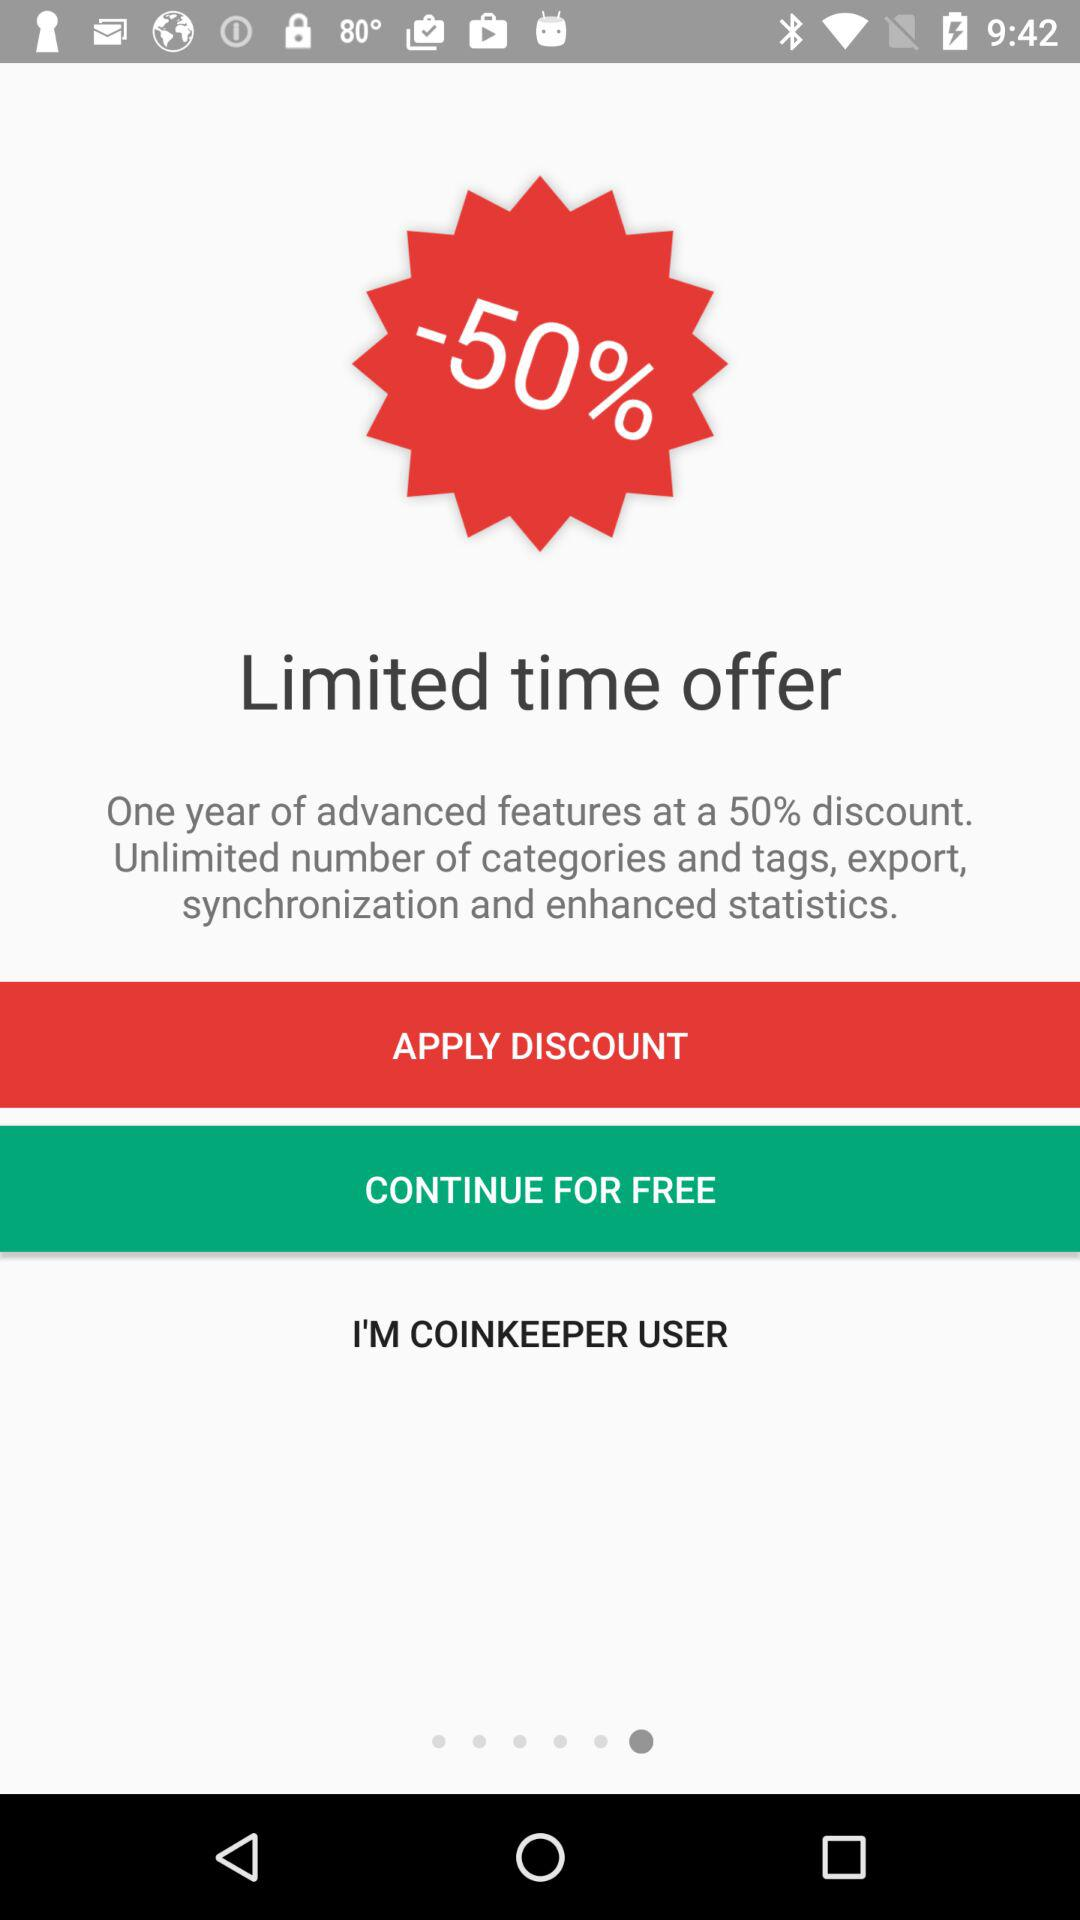How much of a discount is there for the one-year advanced features? There is a 50% discount for one-year advanced features. 